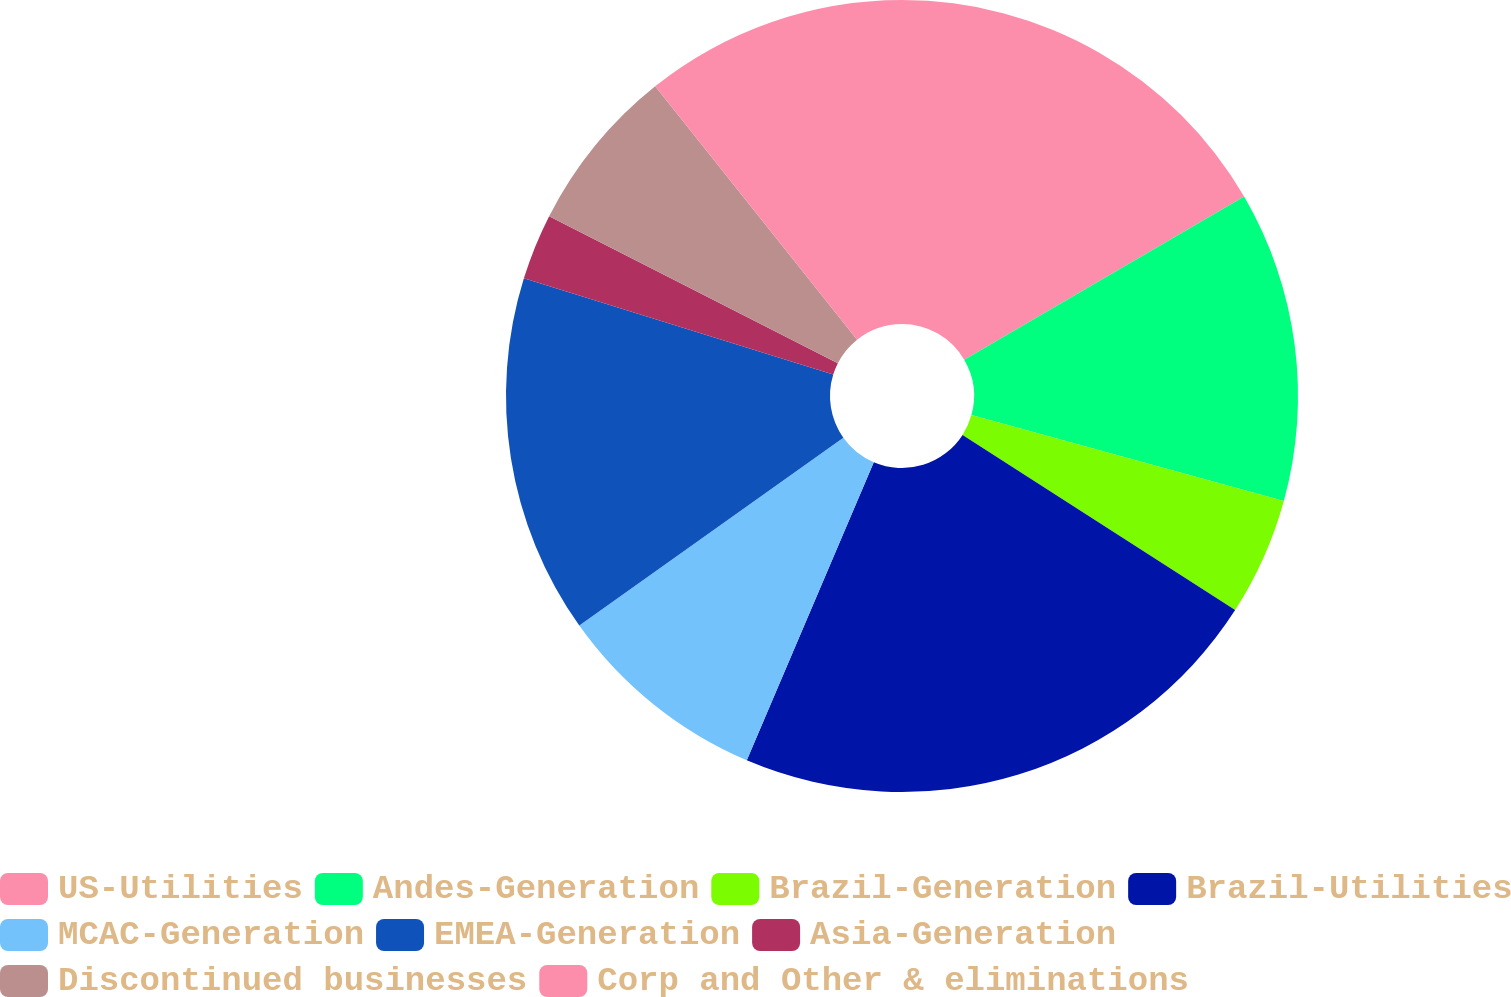Convert chart. <chart><loc_0><loc_0><loc_500><loc_500><pie_chart><fcel>US-Utilities<fcel>Andes-Generation<fcel>Brazil-Generation<fcel>Brazil-Utilities<fcel>MCAC-Generation<fcel>EMEA-Generation<fcel>Asia-Generation<fcel>Discontinued businesses<fcel>Corp and Other & eliminations<nl><fcel>16.6%<fcel>12.67%<fcel>4.82%<fcel>22.32%<fcel>8.75%<fcel>14.64%<fcel>2.7%<fcel>6.79%<fcel>10.71%<nl></chart> 